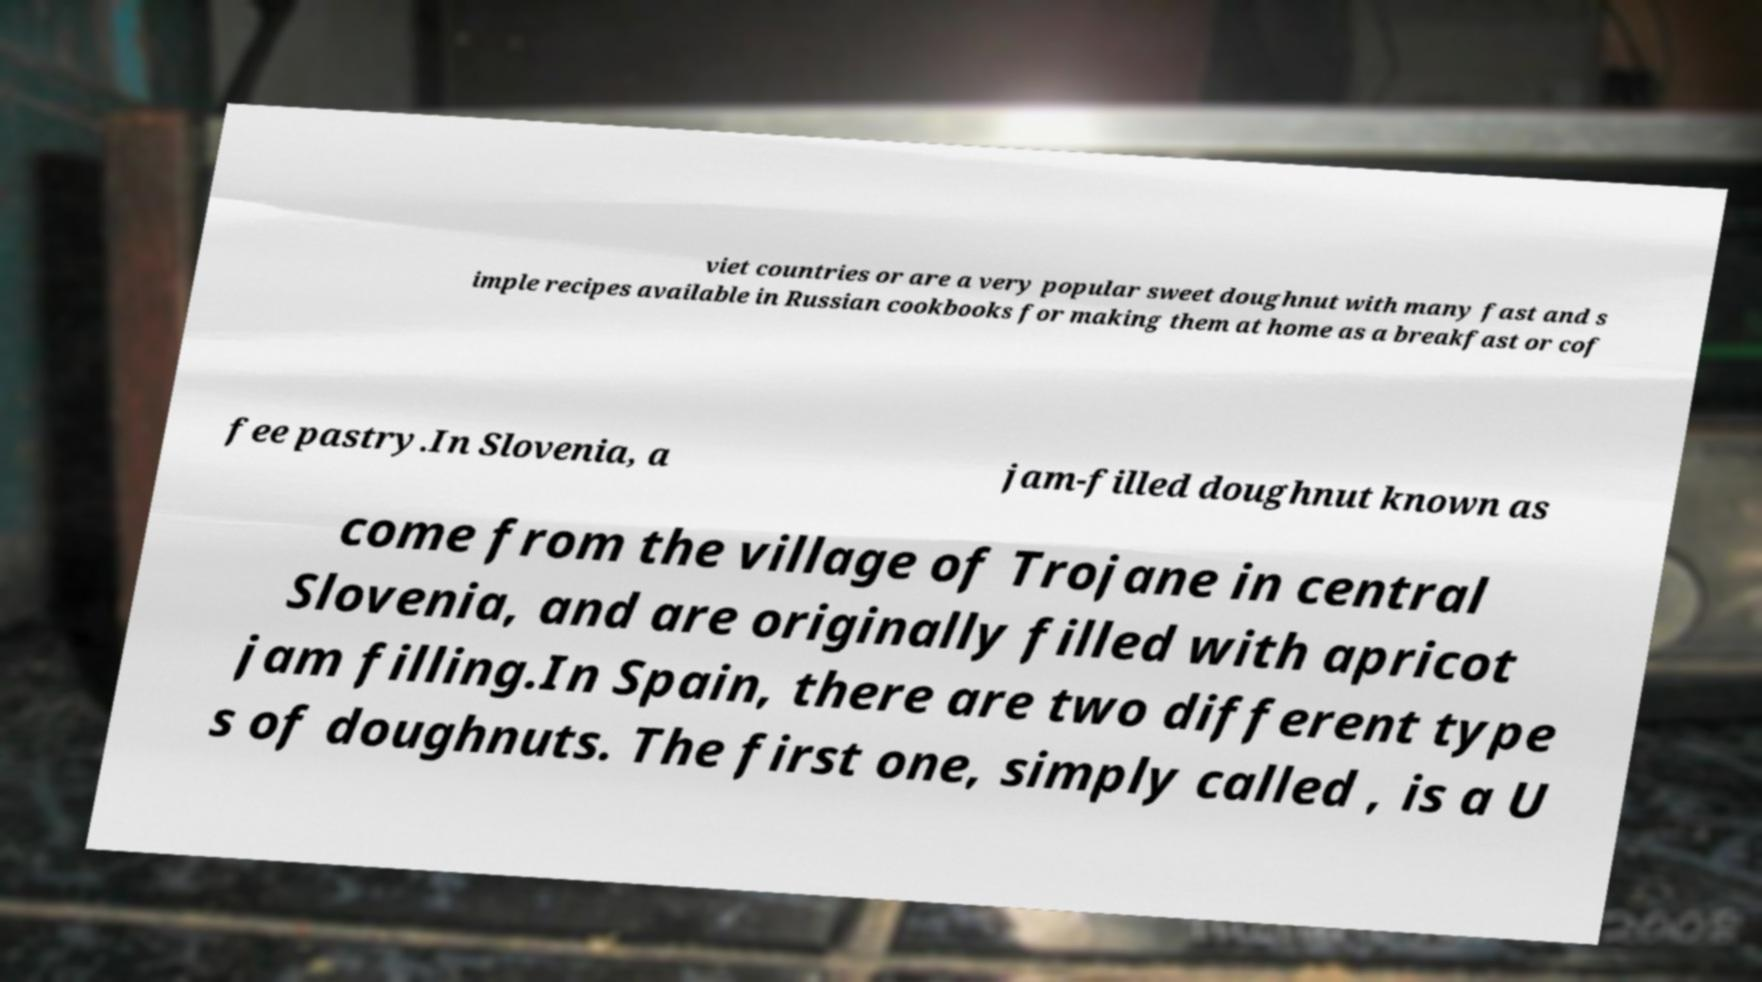Can you read and provide the text displayed in the image?This photo seems to have some interesting text. Can you extract and type it out for me? viet countries or are a very popular sweet doughnut with many fast and s imple recipes available in Russian cookbooks for making them at home as a breakfast or cof fee pastry.In Slovenia, a jam-filled doughnut known as come from the village of Trojane in central Slovenia, and are originally filled with apricot jam filling.In Spain, there are two different type s of doughnuts. The first one, simply called , is a U 